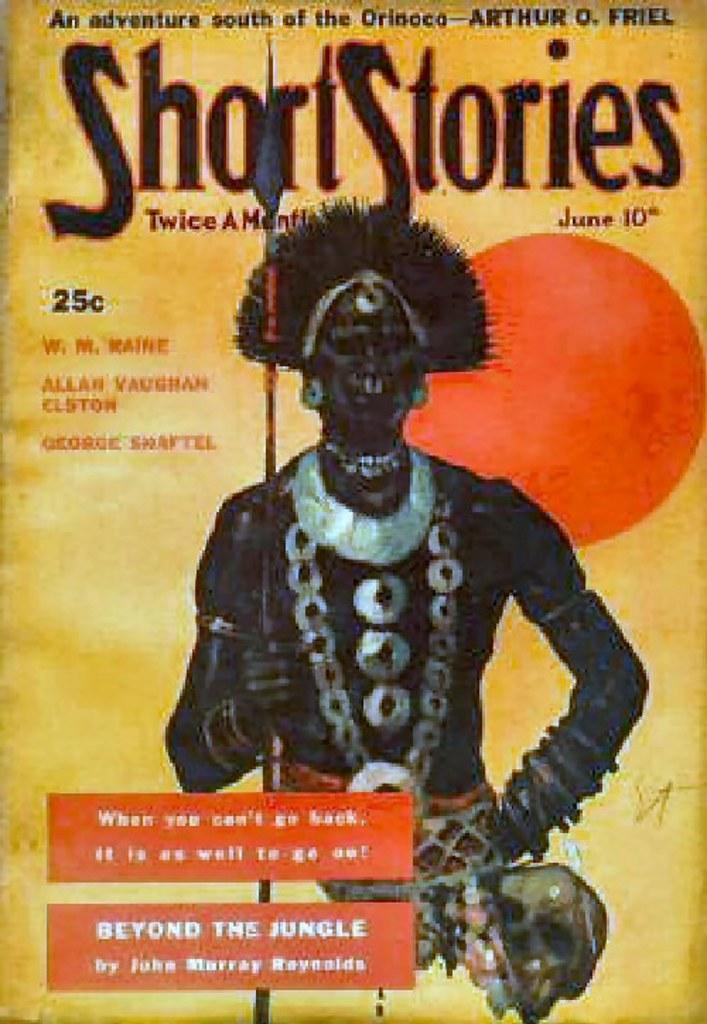Could you give a brief overview of what you see in this image? This is a poster and on this poster we can see a man wore ornaments and holding a tool with his hand and some text. 